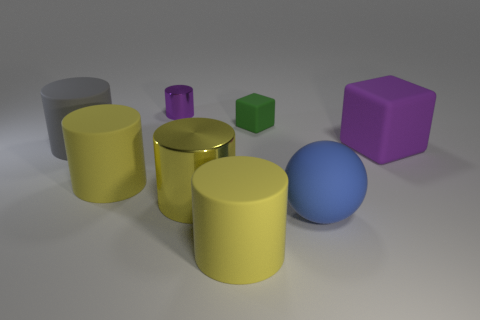Do the big cube and the tiny matte cube have the same color?
Your answer should be compact. No. What number of objects are either small cyan metallic cylinders or large objects to the left of the tiny purple cylinder?
Offer a very short reply. 2. There is a small thing on the right side of the shiny cylinder to the right of the purple cylinder; how many metal things are to the right of it?
Your answer should be compact. 0. What material is the big cube that is the same color as the small metal object?
Offer a very short reply. Rubber. How many gray rubber objects are there?
Provide a short and direct response. 1. There is a purple object in front of the gray thing; does it have the same size as the big blue rubber sphere?
Provide a short and direct response. Yes. How many metal things are tiny purple cylinders or green blocks?
Provide a short and direct response. 1. How many big gray matte objects are left of the big blue thing that is in front of the tiny purple cylinder?
Your answer should be very brief. 1. There is a thing that is both behind the purple matte thing and right of the yellow metal cylinder; what is its shape?
Offer a very short reply. Cube. There is a yellow cylinder that is left of the purple object behind the purple thing that is in front of the gray object; what is it made of?
Your response must be concise. Rubber. 